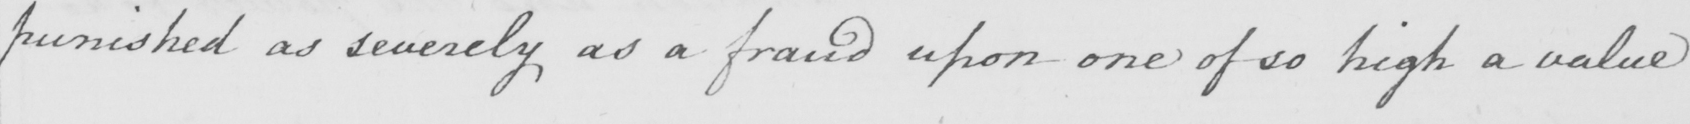Please provide the text content of this handwritten line. punished as severely as a fraud upon one of so high a value 